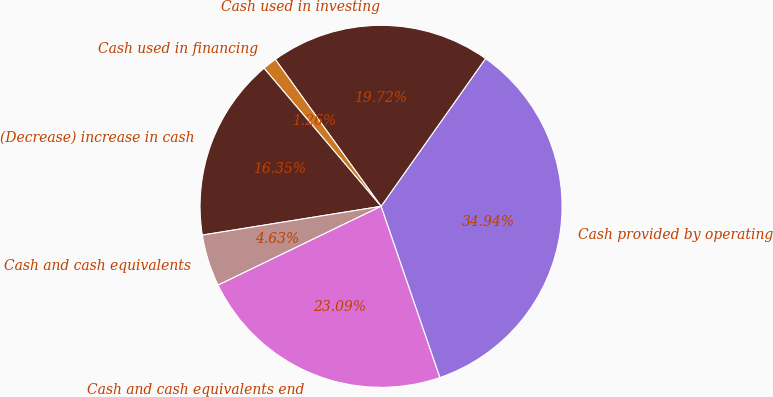<chart> <loc_0><loc_0><loc_500><loc_500><pie_chart><fcel>Cash provided by operating<fcel>Cash used in investing<fcel>Cash used in financing<fcel>(Decrease) increase in cash<fcel>Cash and cash equivalents<fcel>Cash and cash equivalents end<nl><fcel>34.94%<fcel>19.72%<fcel>1.26%<fcel>16.35%<fcel>4.63%<fcel>23.09%<nl></chart> 